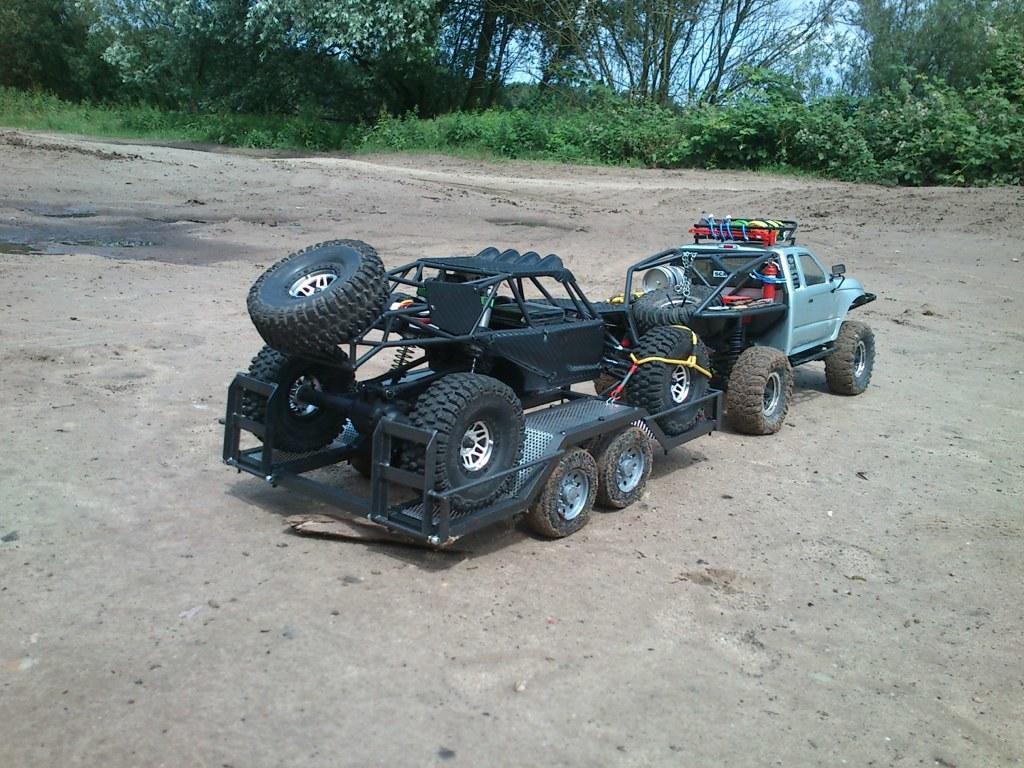Could you give a brief overview of what you see in this image? In this image, we can see vehicles on the road and in the background, there are trees and plants. 